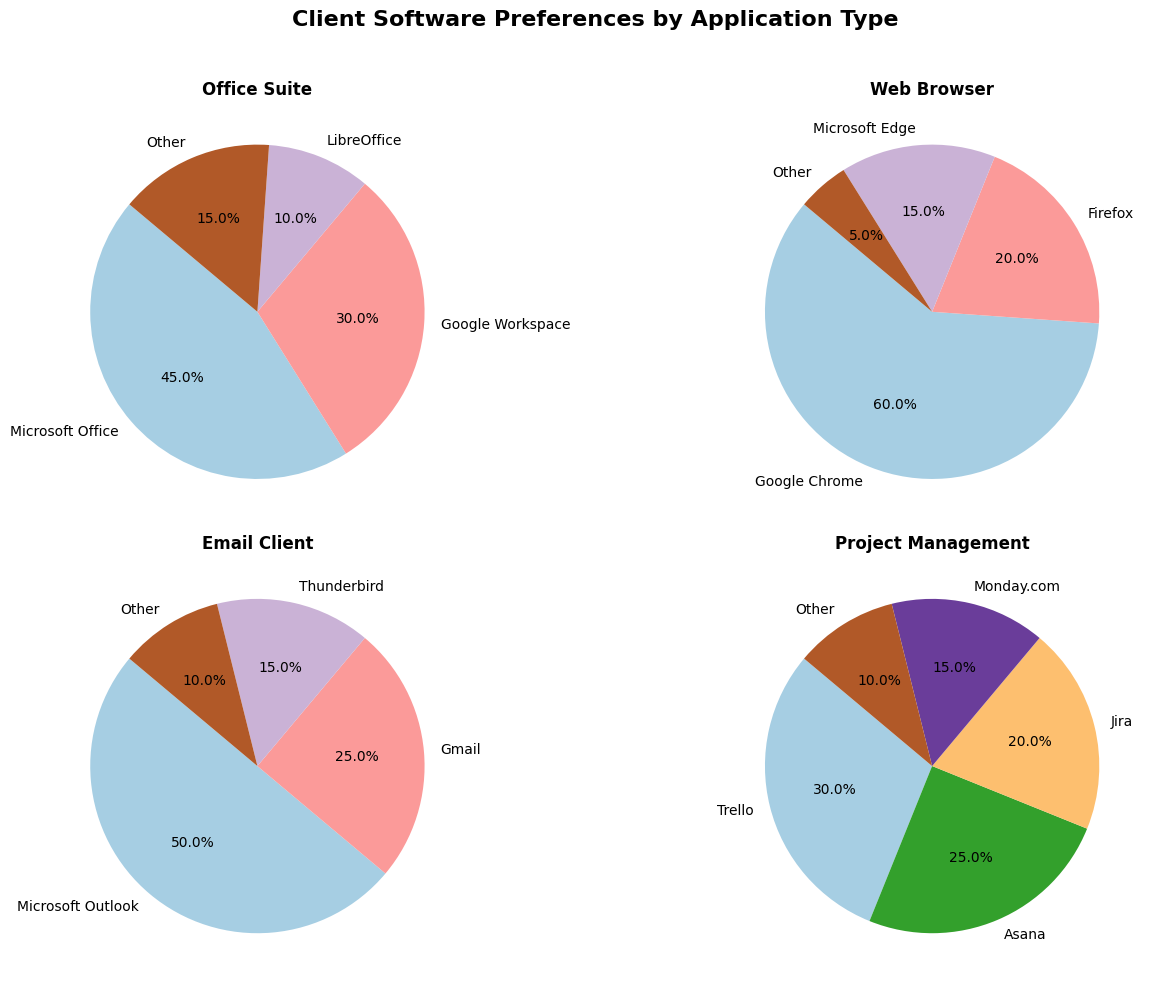Which application type has the most software categories? Observe the number of categories for each application type in the pie charts. Office Suite, Web Browser, and Project Management each have five software categories, while Email Client has four, making Office Suite, Web Browser, and Project Management the ones with the most categories.
Answer: Office Suite, Web Browser, Project Management In the Office Suite category, how much greater is the percentage for Microsoft Office compared to LibreOffice? The percentage for Microsoft Office in the Office Suite category is 45%, and for LibreOffice, it is 10%. The difference is 45% - 10%.
Answer: 35% Which software has the highest preference in the Web Browser category? Look at the Web Browser pie chart and identify the software with the largest slice. Google Chrome has the highest slice indicating 60%.
Answer: Google Chrome Among all Office Suite software, what is the combined percentage for Microsoft Office and Google Workspace? Sum the percentages of Microsoft Office (45%) and Google Workspace (30%). The combined percentage is 45% + 30%.
Answer: 75% Which application type has the closest percentage distribution among its software choices? Compare the slices in each pie chart to see which one has the most equal distribution across different categories. The Email Client category has a relatively balanced distribution among its options (Microsoft Outlook 50%, Gmail 25%, Thunderbird 15%, Other 10%).
Answer: Email Client Between Trello and Asana in Project Management, which software has a higher preference and by how much? Trello has a percentage of 30% and Asana has 25% in Project Management. The difference is Trello 30% - Asana 25%.
Answer: Trello by 5% In the Email Client category, what is the total percentage of preferences for Microsoft Outlook and Other combined? Combine the percentages for Microsoft Outlook (50%) and Other (10%) in the Email Client category. The total is 50% + 10%.
Answer: 60% Which software has the smallest preference in the Web Browser category, and what is its percentage? Look for the smallest slice in the Web Browser pie chart. The smallest slice represents "Other" with a percentage of 5%.
Answer: Other, 5% How does the combined percentage for Google Workspace and LibreOffice in Office Suite compare to the percentage for Google Chrome in Web Browser? Add the percentages for Google Workspace (30%) and LibreOffice (10%) in Office Suite to get a combined percentage of 40%. Compare this with Google Chrome's 60% in Web Browser. Google Workspace and LibreOffice together (40%) is 20% less than Google Chrome's 60%.
Answer: 40% vs 60%, Google Chrome is 20% higher 